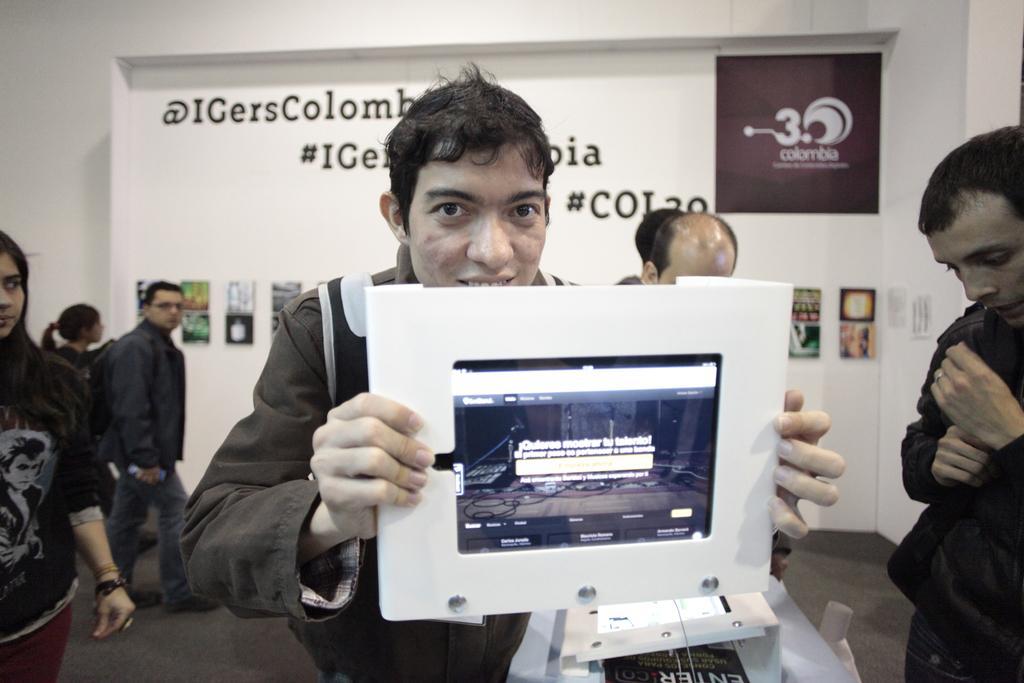Describe this image in one or two sentences. There is a man holding a screen with his hands and there are few persons. In the background we can see a banner and a wall. 